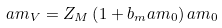<formula> <loc_0><loc_0><loc_500><loc_500>a m _ { V } = Z _ { M } \left ( 1 + b _ { m } a m _ { 0 } \right ) a m _ { 0 }</formula> 